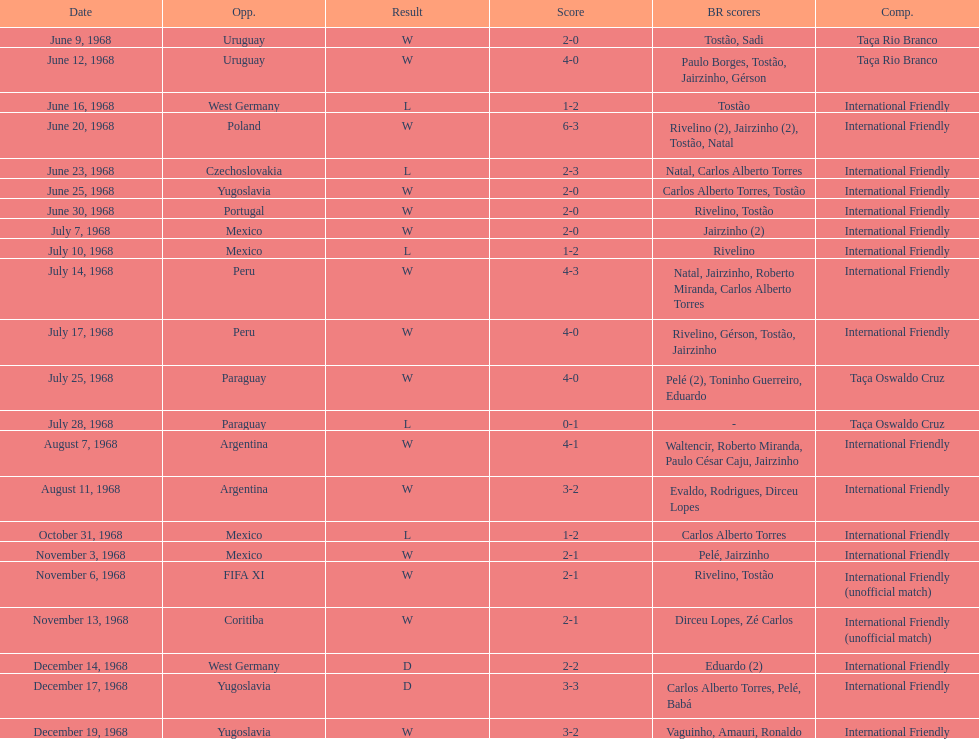Who played brazil previous to the game on june 30th? Yugoslavia. 